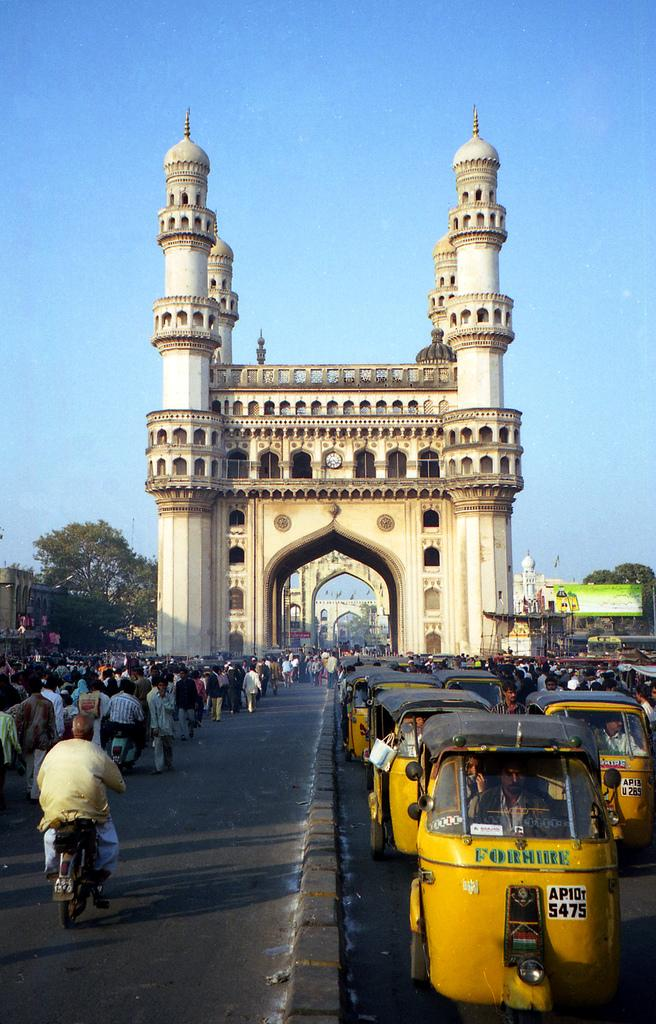<image>
Present a compact description of the photo's key features. The little yellow taxis for hire are all lined up. 